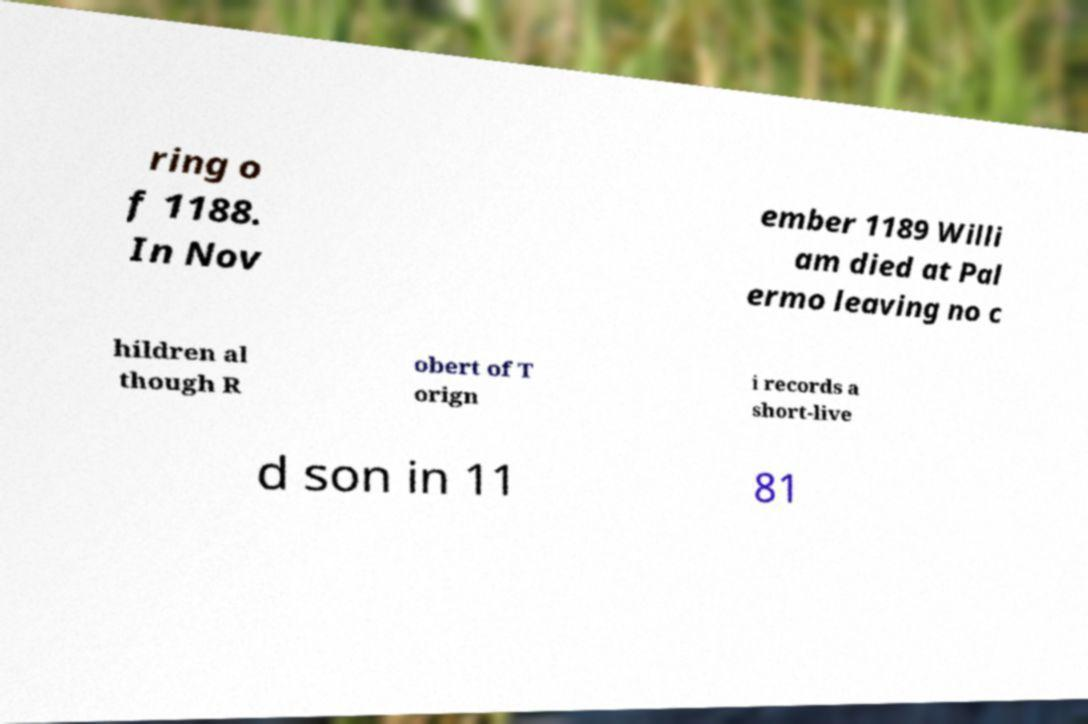I need the written content from this picture converted into text. Can you do that? ring o f 1188. In Nov ember 1189 Willi am died at Pal ermo leaving no c hildren al though R obert of T orign i records a short-live d son in 11 81 